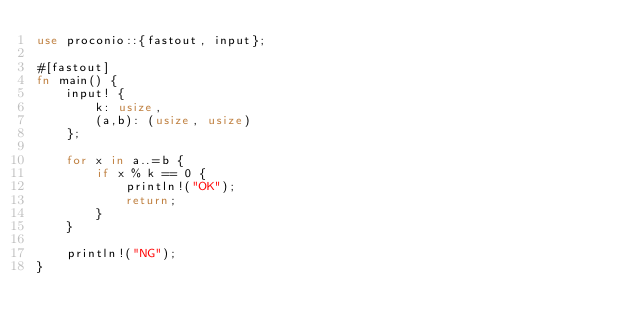Convert code to text. <code><loc_0><loc_0><loc_500><loc_500><_Rust_>use proconio::{fastout, input};

#[fastout]
fn main() {
    input! {
        k: usize,
        (a,b): (usize, usize)
    };

    for x in a..=b {
        if x % k == 0 {
            println!("OK");
            return;
        }
    }

    println!("NG");
}
</code> 